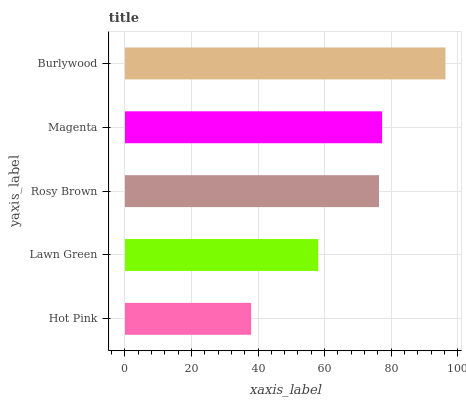Is Hot Pink the minimum?
Answer yes or no. Yes. Is Burlywood the maximum?
Answer yes or no. Yes. Is Lawn Green the minimum?
Answer yes or no. No. Is Lawn Green the maximum?
Answer yes or no. No. Is Lawn Green greater than Hot Pink?
Answer yes or no. Yes. Is Hot Pink less than Lawn Green?
Answer yes or no. Yes. Is Hot Pink greater than Lawn Green?
Answer yes or no. No. Is Lawn Green less than Hot Pink?
Answer yes or no. No. Is Rosy Brown the high median?
Answer yes or no. Yes. Is Rosy Brown the low median?
Answer yes or no. Yes. Is Lawn Green the high median?
Answer yes or no. No. Is Magenta the low median?
Answer yes or no. No. 